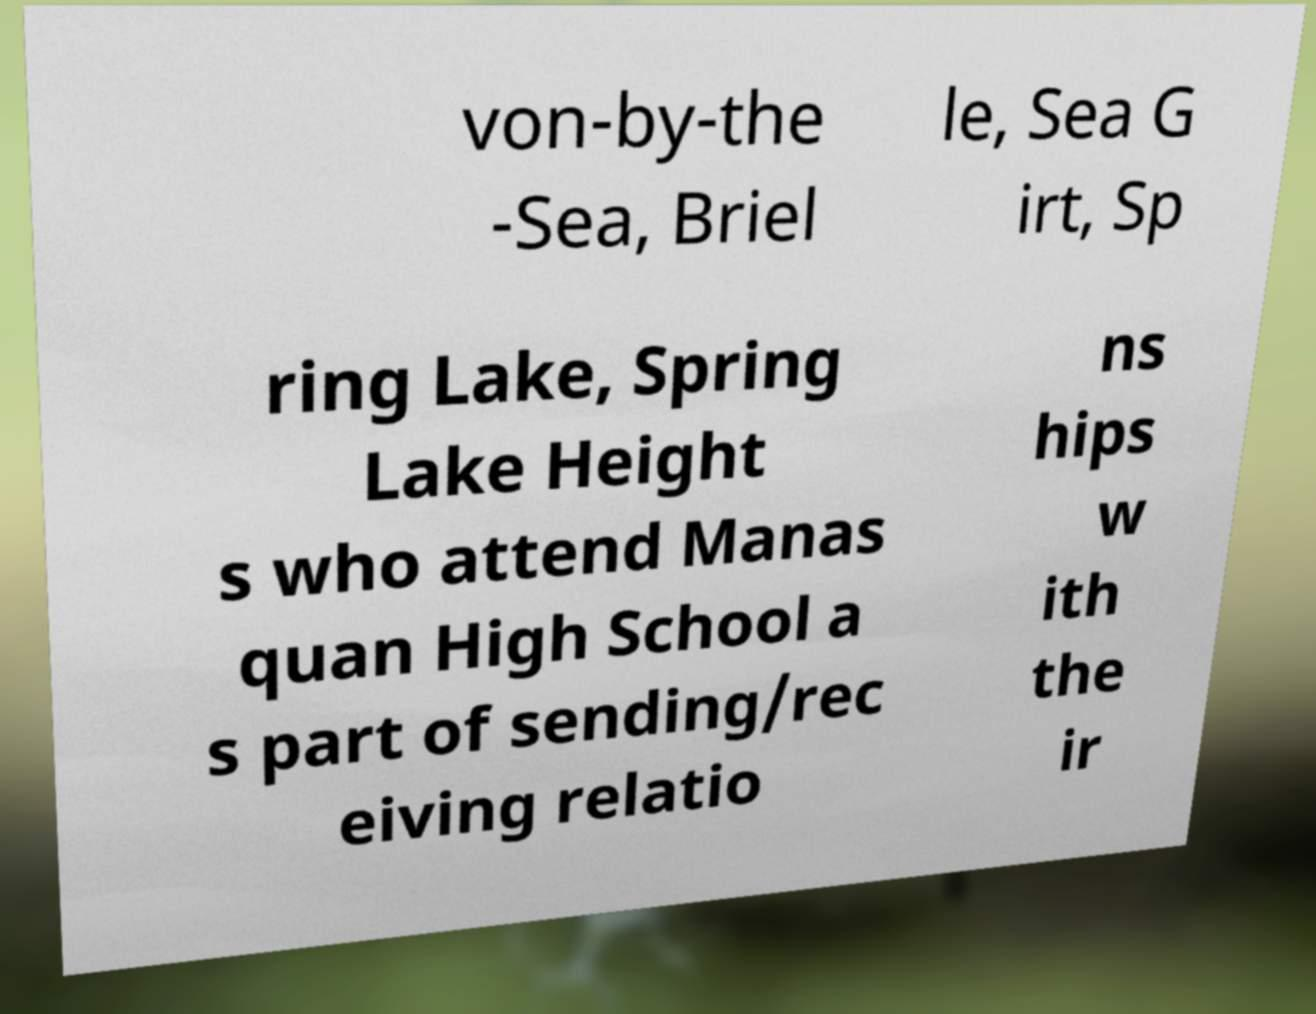Could you assist in decoding the text presented in this image and type it out clearly? von-by-the -Sea, Briel le, Sea G irt, Sp ring Lake, Spring Lake Height s who attend Manas quan High School a s part of sending/rec eiving relatio ns hips w ith the ir 